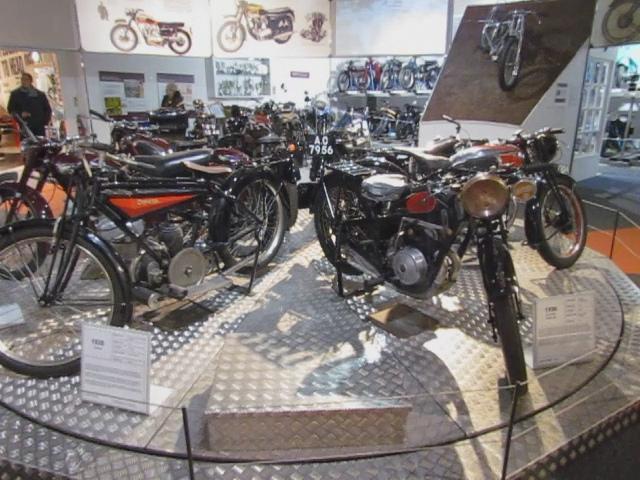How many motorcycles are in the photo?
Give a very brief answer. 7. How many beds are in the picture?
Give a very brief answer. 0. 